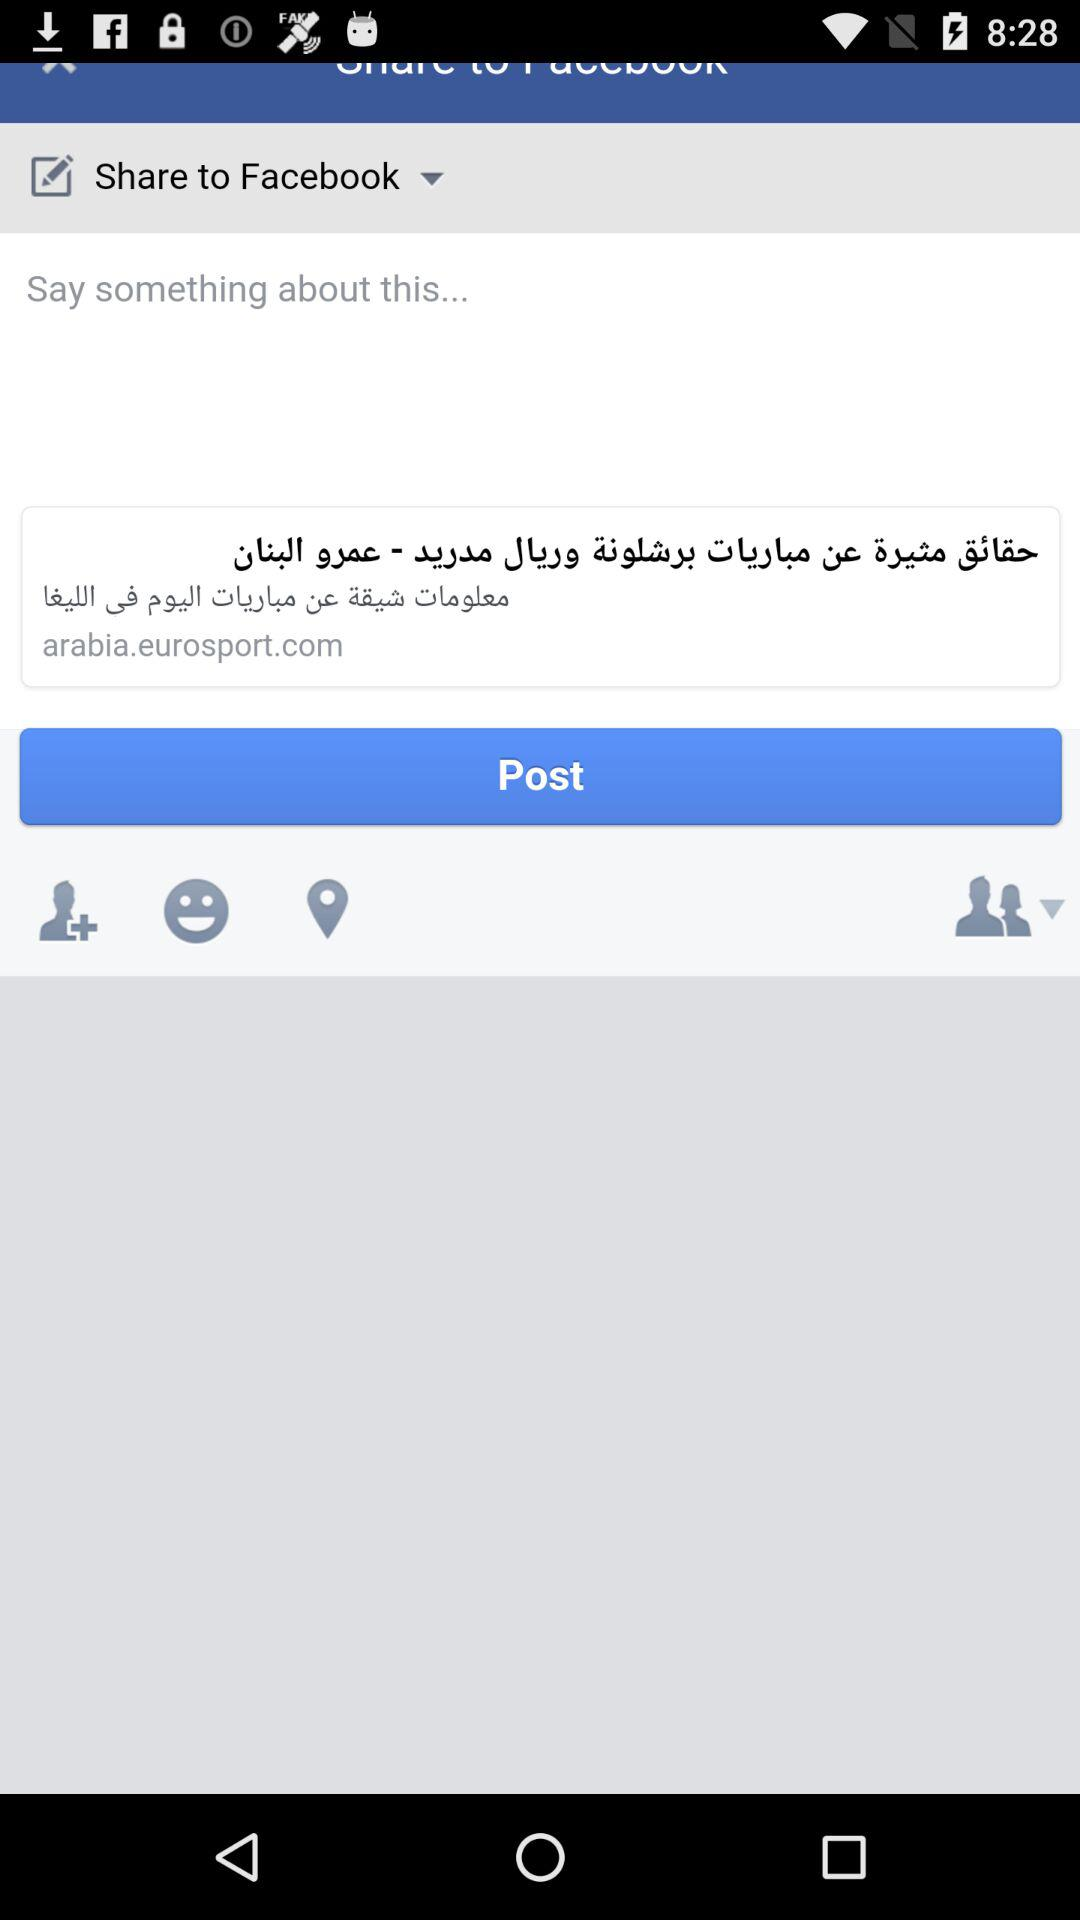Which option is selected to share? The selected option is "Share to Facebook". 